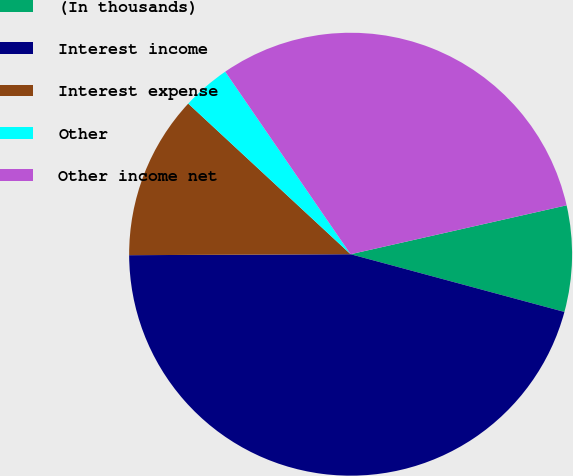Convert chart to OTSL. <chart><loc_0><loc_0><loc_500><loc_500><pie_chart><fcel>(In thousands)<fcel>Interest income<fcel>Interest expense<fcel>Other<fcel>Other income net<nl><fcel>7.74%<fcel>45.73%<fcel>11.97%<fcel>3.52%<fcel>31.03%<nl></chart> 